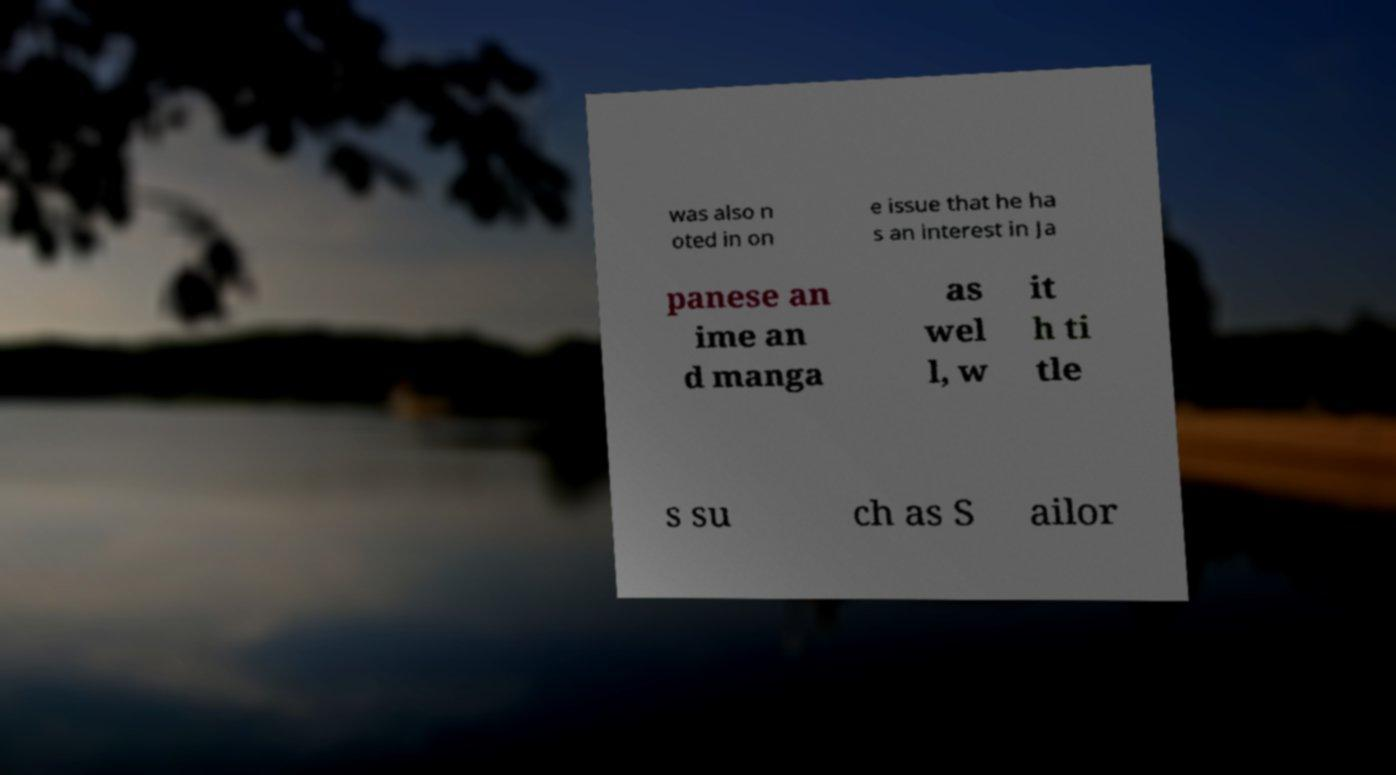Please read and relay the text visible in this image. What does it say? was also n oted in on e issue that he ha s an interest in Ja panese an ime an d manga as wel l, w it h ti tle s su ch as S ailor 